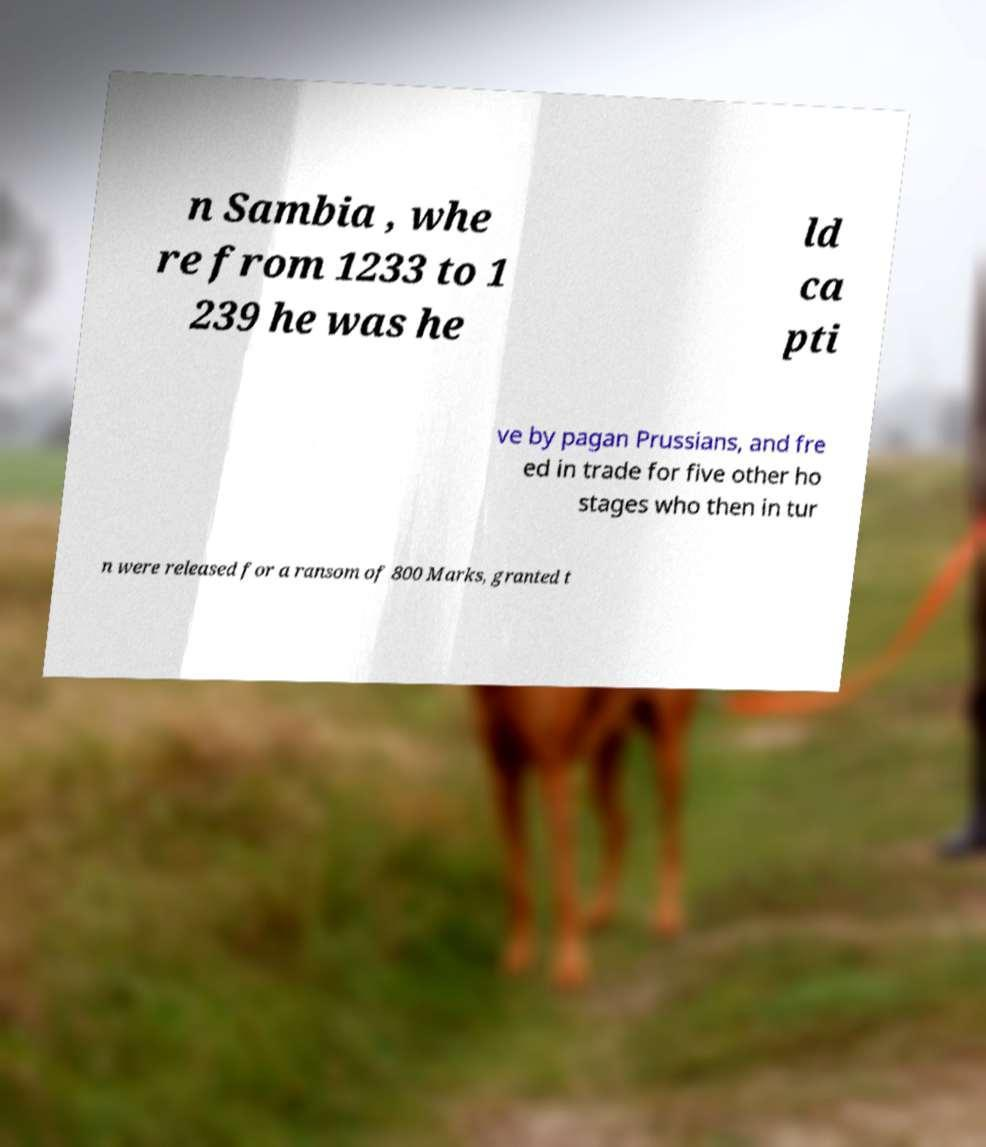Please read and relay the text visible in this image. What does it say? n Sambia , whe re from 1233 to 1 239 he was he ld ca pti ve by pagan Prussians, and fre ed in trade for five other ho stages who then in tur n were released for a ransom of 800 Marks, granted t 